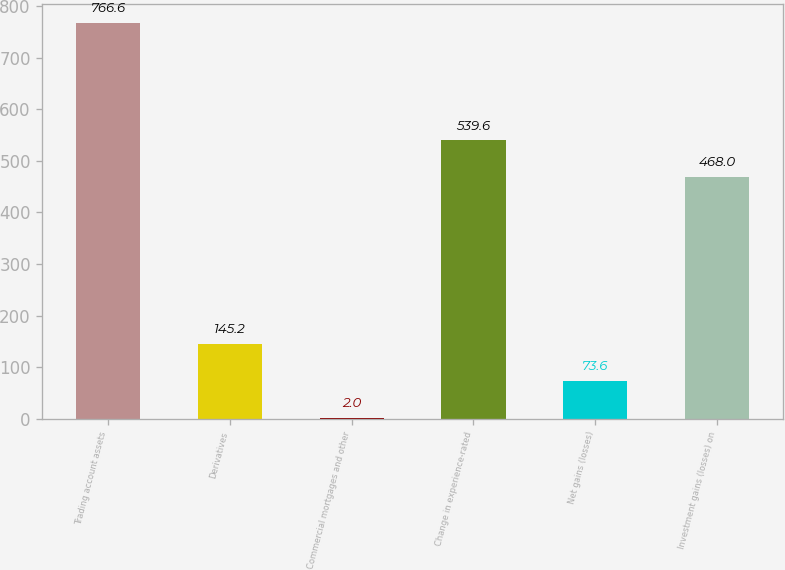<chart> <loc_0><loc_0><loc_500><loc_500><bar_chart><fcel>Trading account assets<fcel>Derivatives<fcel>Commercial mortgages and other<fcel>Change in experience-rated<fcel>Net gains (losses)<fcel>Investment gains (losses) on<nl><fcel>766.6<fcel>145.2<fcel>2<fcel>539.6<fcel>73.6<fcel>468<nl></chart> 